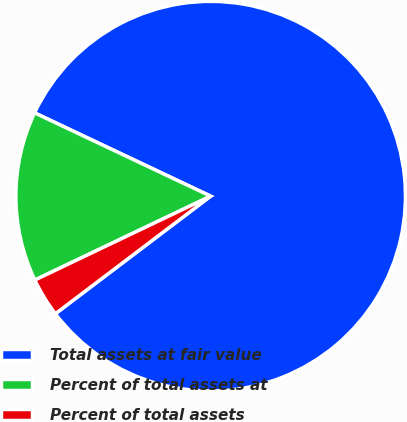Convert chart. <chart><loc_0><loc_0><loc_500><loc_500><pie_chart><fcel>Total assets at fair value<fcel>Percent of total assets at<fcel>Percent of total assets<nl><fcel>82.65%<fcel>14.12%<fcel>3.23%<nl></chart> 